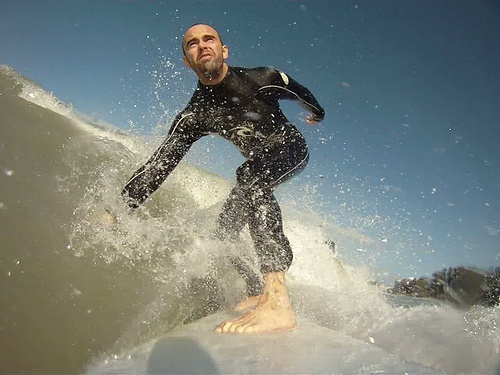Describe the objects in this image and their specific colors. I can see people in blue, black, gray, tan, and darkgray tones and surfboard in blue, darkgray, tan, and gray tones in this image. 